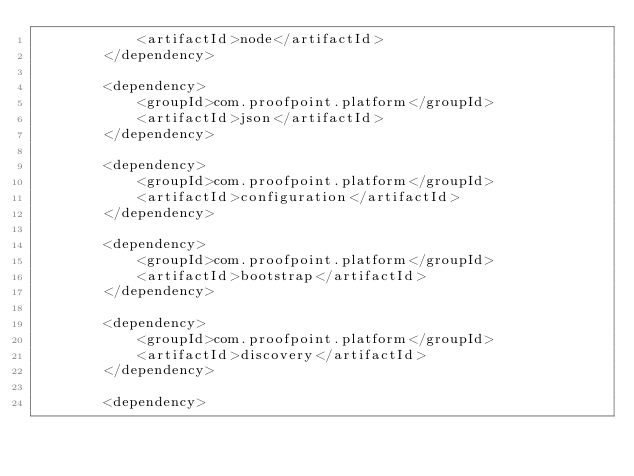<code> <loc_0><loc_0><loc_500><loc_500><_XML_>            <artifactId>node</artifactId>
        </dependency>

        <dependency>
            <groupId>com.proofpoint.platform</groupId>
            <artifactId>json</artifactId>
        </dependency>

        <dependency>
            <groupId>com.proofpoint.platform</groupId>
            <artifactId>configuration</artifactId>
        </dependency>

        <dependency>
            <groupId>com.proofpoint.platform</groupId>
            <artifactId>bootstrap</artifactId>
        </dependency>

        <dependency>
            <groupId>com.proofpoint.platform</groupId>
            <artifactId>discovery</artifactId>
        </dependency>

        <dependency></code> 